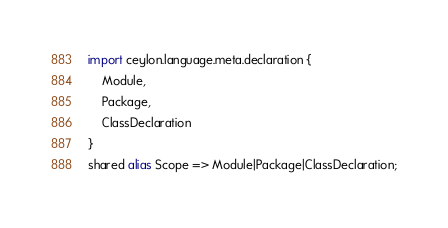<code> <loc_0><loc_0><loc_500><loc_500><_Ceylon_>import ceylon.language.meta.declaration {
	Module,
	Package,
	ClassDeclaration
}
shared alias Scope => Module|Package|ClassDeclaration;</code> 